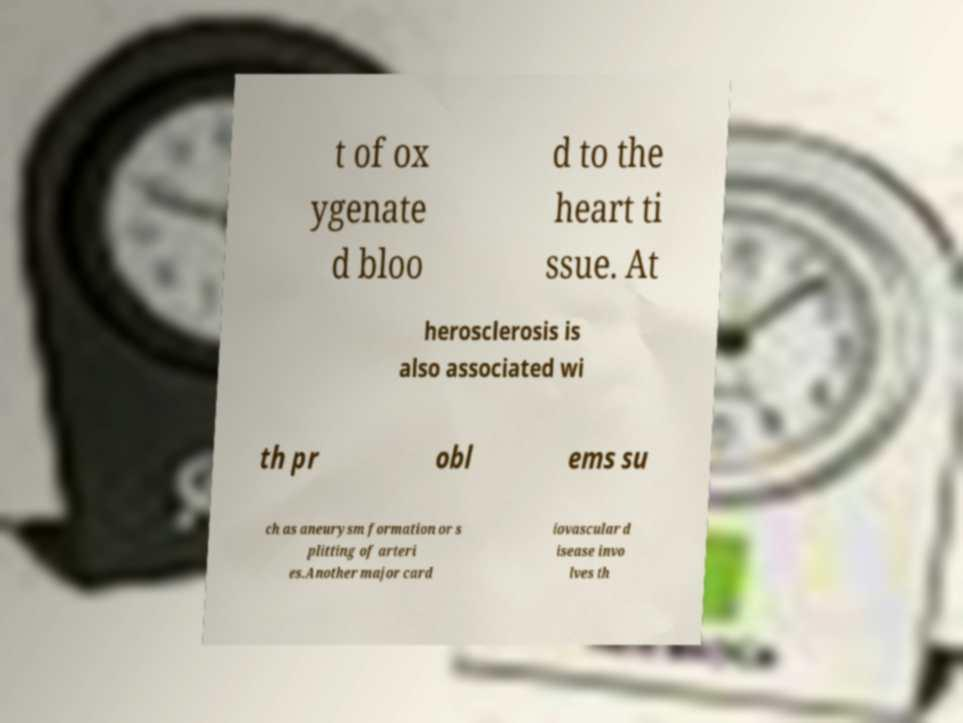Please identify and transcribe the text found in this image. t of ox ygenate d bloo d to the heart ti ssue. At herosclerosis is also associated wi th pr obl ems su ch as aneurysm formation or s plitting of arteri es.Another major card iovascular d isease invo lves th 